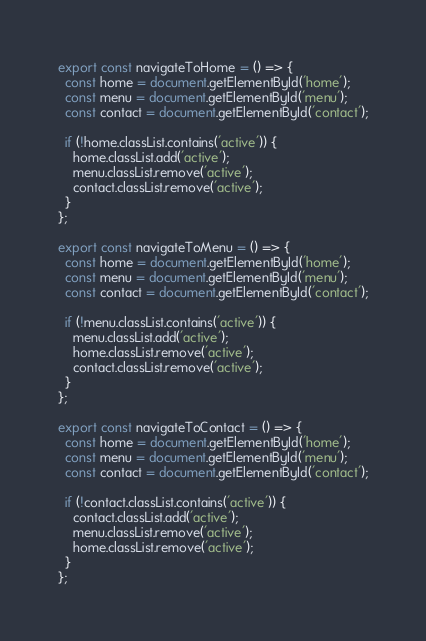Convert code to text. <code><loc_0><loc_0><loc_500><loc_500><_JavaScript_>export const navigateToHome = () => {
  const home = document.getElementById('home');
  const menu = document.getElementById('menu');
  const contact = document.getElementById('contact');

  if (!home.classList.contains('active')) {
    home.classList.add('active');
    menu.classList.remove('active');
    contact.classList.remove('active');
  }
};

export const navigateToMenu = () => {
  const home = document.getElementById('home');
  const menu = document.getElementById('menu');
  const contact = document.getElementById('contact');

  if (!menu.classList.contains('active')) {
    menu.classList.add('active');
    home.classList.remove('active');
    contact.classList.remove('active');
  }
};

export const navigateToContact = () => {
  const home = document.getElementById('home');
  const menu = document.getElementById('menu');
  const contact = document.getElementById('contact');

  if (!contact.classList.contains('active')) {
    contact.classList.add('active');
    menu.classList.remove('active');
    home.classList.remove('active');
  }
};</code> 